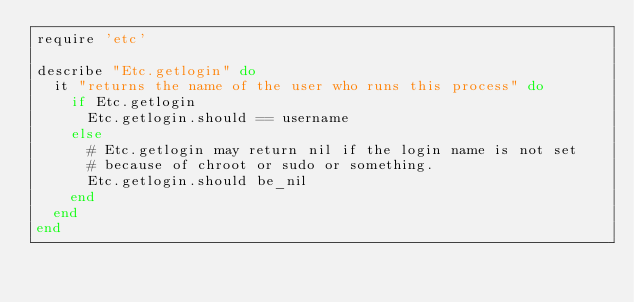Convert code to text. <code><loc_0><loc_0><loc_500><loc_500><_Ruby_>require 'etc'

describe "Etc.getlogin" do
  it "returns the name of the user who runs this process" do
    if Etc.getlogin
      Etc.getlogin.should == username
    else
      # Etc.getlogin may return nil if the login name is not set
      # because of chroot or sudo or something.
      Etc.getlogin.should be_nil
    end
  end
end
</code> 